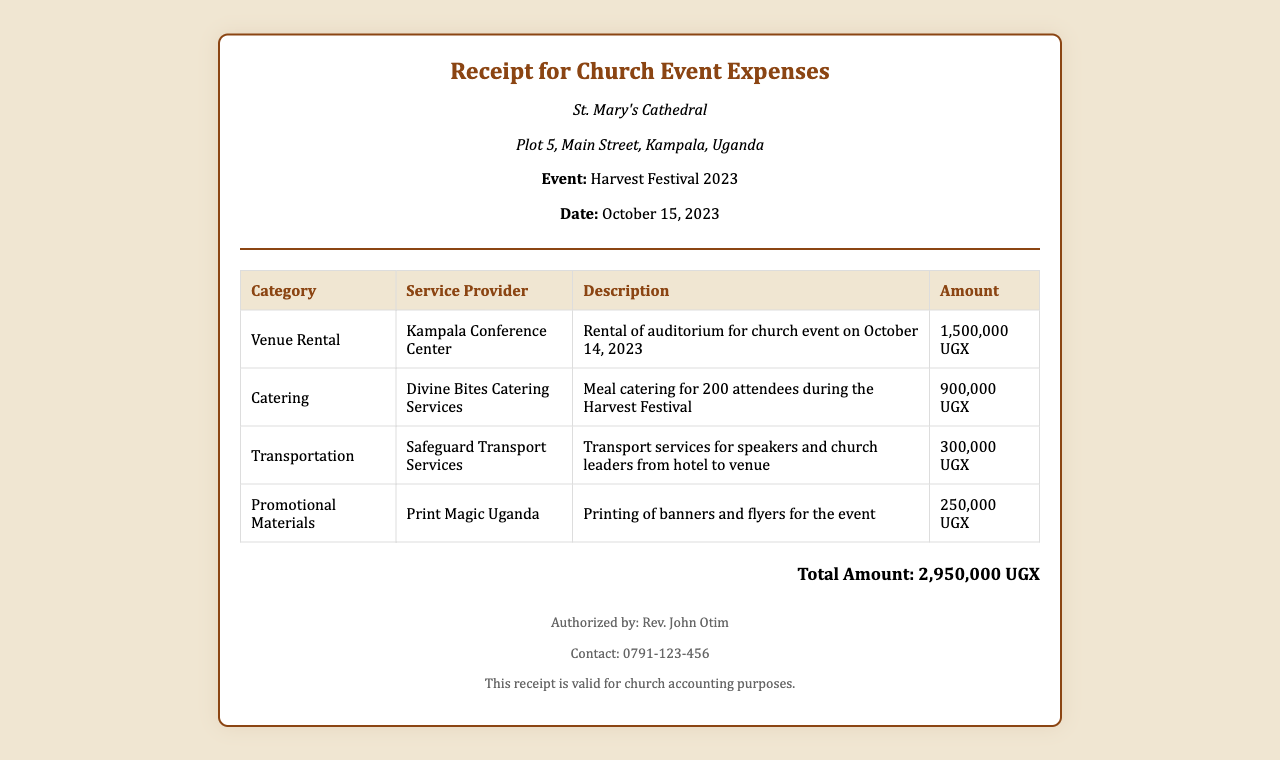what is the total amount? The total amount is clearly stated in the receipt as the sum of all expenses incurred during the event.
Answer: 2,950,000 UGX who authorized the receipt? The receipt mentions an authorized individual for validation, which is typically important for accountability in church documents.
Answer: Rev. John Otim what was the venue for the event? The venue for the church event is specifically indicated, which helps in identifying where the expenses were incurred.
Answer: Kampala Conference Center how many attendees were catered for? The document details the number of people catered for during the event, which is crucial for planning and budgeting purposes.
Answer: 200 what was the service provider for catering? Each expense includes the name of the service provider, which is important for tracking expenses and service quality.
Answer: Divine Bites Catering Services when did the church event take place? The date of the event is provided in the document, important for record-keeping and future reference.
Answer: October 15, 2023 what is the amount for transportation costs? Specific amounts for each category are included, providing a clear breakdown of expenses for accountability.
Answer: 300,000 UGX what type of event is this receipt for? The nature of the event can influence the type of expenses incurred, thus it's stated clearly in the document.
Answer: Harvest Festival 2023 what is the description of the promotional materials expense? Descriptions of each expense category give context and justification for the costs incurred, which is helpful during financial reviews.
Answer: Printing of banners and flyers for the event 